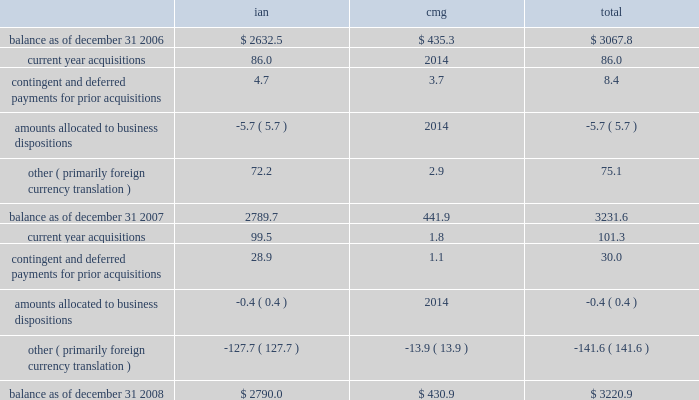Notes to consolidated financial statements 2014 ( continued ) ( amounts in millions , except per share amounts ) litigation settlement 2014 during may 2008 , the sec concluded its investigation that began in 2002 into our financial reporting practices , resulting in a settlement charge of $ 12.0 .
Investment impairments 2014 in 2007 we realized an other-than-temporary charge of $ 5.8 relating to a $ 12.5 investment in auction rate securities , representing our total investment in auction rate securities .
For additional information see note 15 .
Note 6 : intangible assets goodwill goodwill is the excess purchase price remaining from an acquisition after an allocation of purchase price has been made to identifiable assets acquired and liabilities assumed based on estimated fair values .
The changes in the carrying value of goodwill by segment for the years ended december 31 , 2008 and 2007 are as follows: .
During the latter part of the fourth quarter of 2008 our stock price declined significantly after our annual impairment review as of october 1 , 2008 , and our market capitalization was less than our book value as of december 31 , 2008 .
We considered whether there were any events or circumstances indicative of a triggering event and determined that the decline in stock price during the fourth quarter was an event that would 201cmore likely than not 201d reduce the fair value of our individual reporting units below their book value , requiring us to perform an interim impairment test for goodwill at the reporting unit level .
Based on the interim impairment test conducted , we concluded that there was no impairment of our goodwill as of december 31 , 2008 .
We will continue to monitor our stock price as it relates to the reconciliation of our market capitalization and the fair values of our individual reporting units throughout 2009 .
During our annual impairment reviews as of october 1 , 2006 our discounted future operating cash flow projections at one of our domestic advertising reporting units indicated that the implied fair value of the goodwill at this reporting unit was less than its book value , primarily due to client losses , resulting in a goodwill impairment charge of $ 27.2 in 2006 in our ian segment .
Other intangible assets included in other intangible assets are assets with indefinite lives not subject to amortization and assets with definite lives subject to amortization .
Other intangible assets include non-compete agreements , license costs , trade names and customer lists .
Intangible assets with definitive lives subject to amortization are amortized on a .
What was the percentage change in total goodwill carrying value from 2006 to 2007? 
Computations: ((3231.6 - 3067.8) / 3067.8)
Answer: 0.05339. 